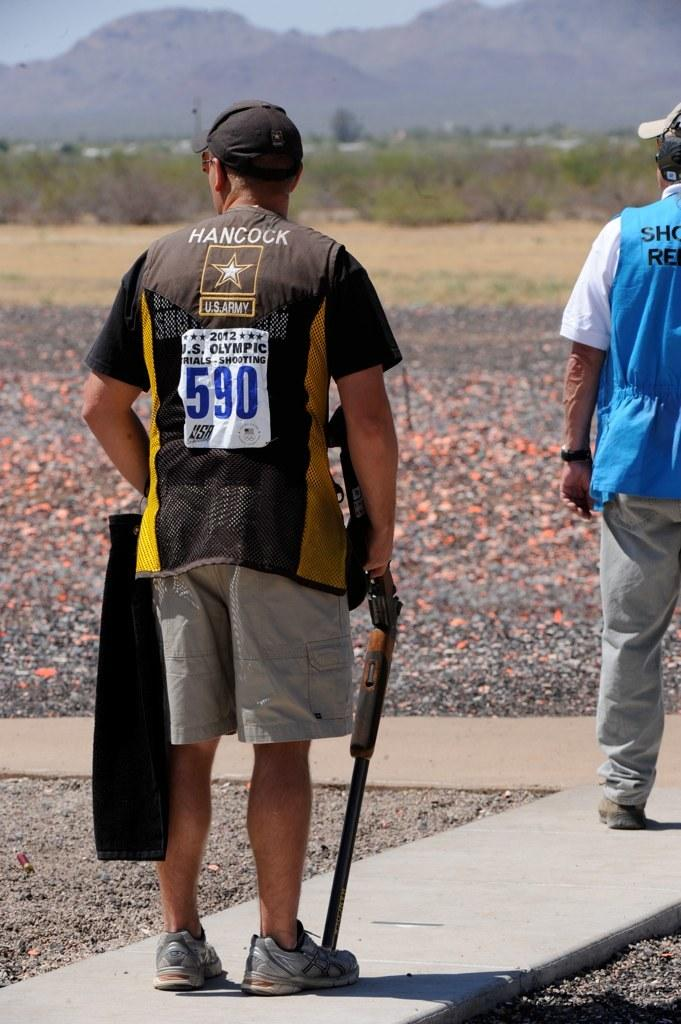Provide a one-sentence caption for the provided image. A man with the number 590 on his back is holding a shotgun. 